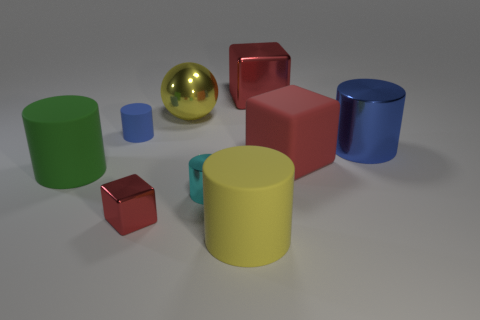Subtract 1 cylinders. How many cylinders are left? 4 Subtract all spheres. How many objects are left? 8 Add 1 big red metallic blocks. How many big red metallic blocks are left? 2 Add 2 big red cylinders. How many big red cylinders exist? 2 Subtract 0 cyan blocks. How many objects are left? 9 Subtract all blue metal cylinders. Subtract all small cyan shiny cylinders. How many objects are left? 7 